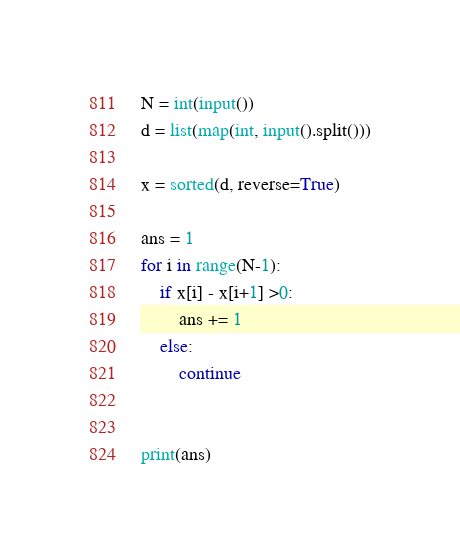<code> <loc_0><loc_0><loc_500><loc_500><_Python_>N = int(input())
d = list(map(int, input().split()))

x = sorted(d, reverse=True)

ans = 1
for i in range(N-1):
    if x[i] - x[i+1] >0:
        ans += 1
    else:
        continue


print(ans)
</code> 